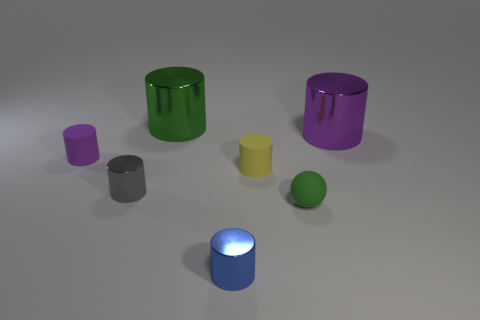What purpose might these objects serve if they were part of a larger installation or exhibit? If these objects were part of a larger installation or exhibit, they might serve several educational or aesthetic purposes. They could be used to teach principles of geometry, light, and shadow, as well as material properties in a visual arts context. Alternatively, they could be a component of an interactive display, where visitors might be invited to observe the effects of lighting on different surfaces or to solve puzzles involving the arrangement and properties of the shapes. The simplicity and clarity of the shapes and materials make them ideal for such instructional and exploratory uses. 